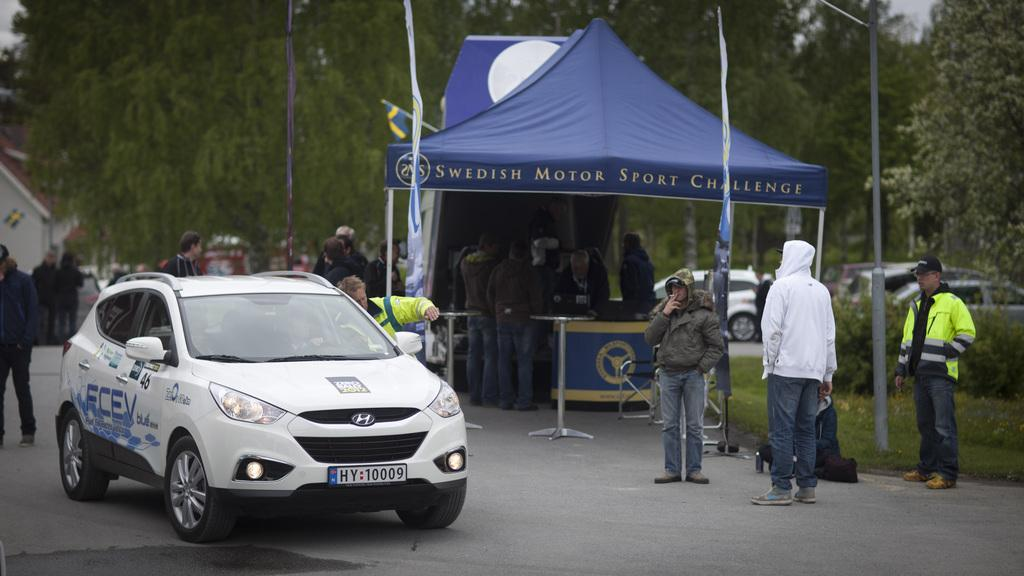What type of vehicle is in the image? There is a white color car in the image. Who or what else can be seen in the image? People are present in the image. Where are the people located in the image? The people are at the bottom of the image. What structure is in the middle of the image? There is a tent in the middle of the image. What type of natural scenery is visible in the background of the image? There are trees in the background of the image. How much money is being exchanged between the people in the image? There is no indication of any money exchange in the image. What type of bag is being used by the people in the image? There is no bag visible in the image. 